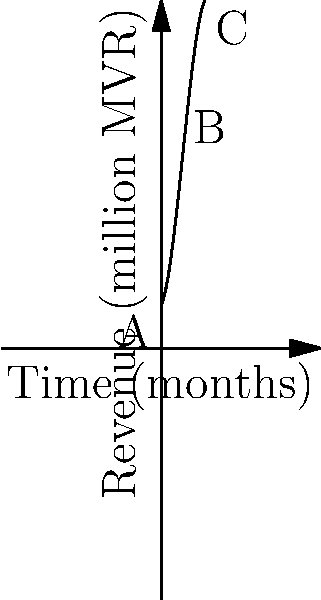The revenue curve of a popular Maldivian resort, where Sara Adam recently performed, is represented by the polynomial function $R(t) = -0.1t^3 + 1.5t^2 + 2t + 10$, where $R$ is the revenue in millions of Maldivian rufiyaa (MVR) and $t$ is the time in months. At which point (A, B, or C) does the resort experience its maximum revenue, and what is the corresponding time? To find the maximum revenue point, we need to follow these steps:

1) The maximum point occurs where the derivative of the function equals zero. Let's find the derivative:
   $R'(t) = -0.3t^2 + 3t + 2$

2) Set the derivative to zero and solve for t:
   $-0.3t^2 + 3t + 2 = 0$

3) This is a quadratic equation. We can solve it using the quadratic formula:
   $t = \frac{-b \pm \sqrt{b^2 - 4ac}}{2a}$

   Where $a = -0.3$, $b = 3$, and $c = 2$

4) Plugging in these values:
   $t = \frac{-3 \pm \sqrt{3^2 - 4(-0.3)(2)}}{2(-0.3)}$

5) Solving this:
   $t \approx 5$ or $t \approx -1.33$

6) Since time can't be negative in this context, we take $t = 5$

7) Looking at the graph, point B is at $t = 5$, which corresponds to the maximum revenue.

Therefore, the resort experiences its maximum revenue at point B, which occurs at 5 months.
Answer: Point B, 5 months 